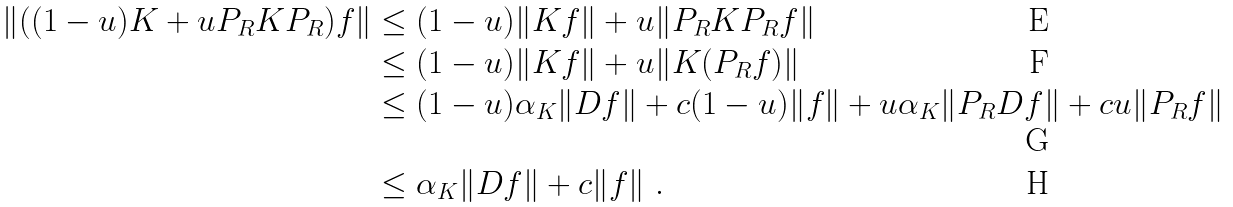Convert formula to latex. <formula><loc_0><loc_0><loc_500><loc_500>\| ( ( 1 - u ) K + u P _ { R } K P _ { R } ) f \| & \leq ( 1 - u ) \| K f \| + u \| P _ { R } K P _ { R } f \| \\ & \leq ( 1 - u ) \| K f \| + u \| K ( P _ { R } f ) \| \\ & \leq ( 1 - u ) \alpha _ { K } \| D f \| + c ( 1 - u ) \| f \| + u \alpha _ { K } \| P _ { R } D f \| + c u \| P _ { R } f \| \\ & \leq \alpha _ { K } \| D f \| + c \| f \| \ .</formula> 